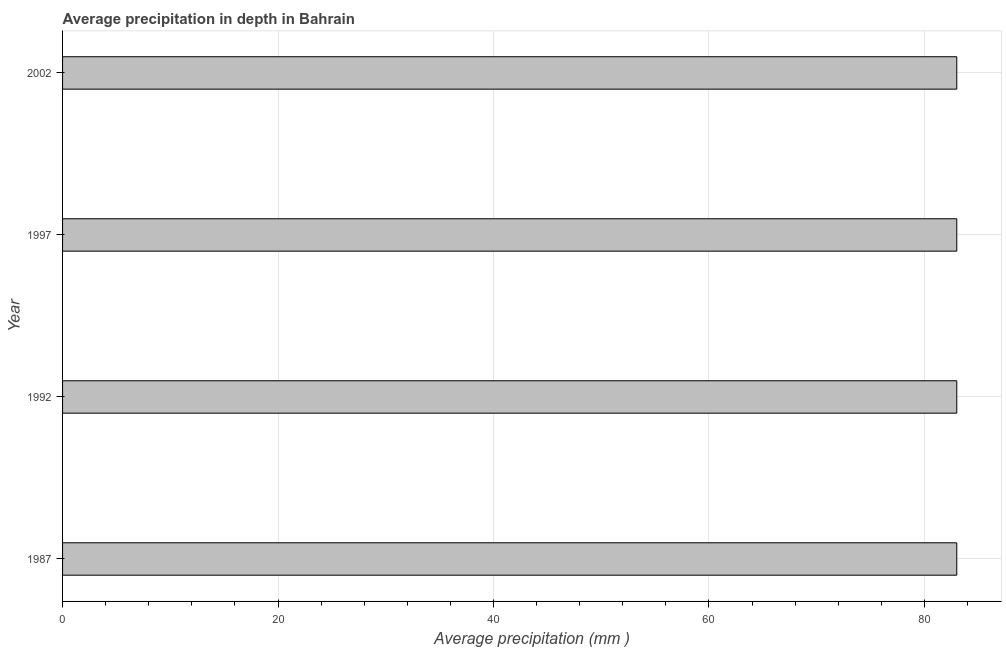Does the graph contain any zero values?
Provide a short and direct response. No. Does the graph contain grids?
Offer a terse response. Yes. What is the title of the graph?
Offer a very short reply. Average precipitation in depth in Bahrain. What is the label or title of the X-axis?
Provide a short and direct response. Average precipitation (mm ). What is the average precipitation in depth in 1997?
Provide a short and direct response. 83. In which year was the average precipitation in depth minimum?
Make the answer very short. 1987. What is the sum of the average precipitation in depth?
Your answer should be compact. 332. What is the difference between the average precipitation in depth in 1987 and 1992?
Give a very brief answer. 0. What is the average average precipitation in depth per year?
Your response must be concise. 83. In how many years, is the average precipitation in depth greater than 24 mm?
Give a very brief answer. 4. Is the difference between the average precipitation in depth in 1987 and 2002 greater than the difference between any two years?
Give a very brief answer. Yes. Is the sum of the average precipitation in depth in 1992 and 2002 greater than the maximum average precipitation in depth across all years?
Keep it short and to the point. Yes. How many bars are there?
Give a very brief answer. 4. Are the values on the major ticks of X-axis written in scientific E-notation?
Provide a succinct answer. No. What is the Average precipitation (mm ) of 1997?
Ensure brevity in your answer.  83. What is the difference between the Average precipitation (mm ) in 1992 and 1997?
Keep it short and to the point. 0. What is the difference between the Average precipitation (mm ) in 1997 and 2002?
Ensure brevity in your answer.  0. What is the ratio of the Average precipitation (mm ) in 1987 to that in 1992?
Provide a short and direct response. 1. What is the ratio of the Average precipitation (mm ) in 1987 to that in 1997?
Ensure brevity in your answer.  1. What is the ratio of the Average precipitation (mm ) in 1992 to that in 1997?
Ensure brevity in your answer.  1. 